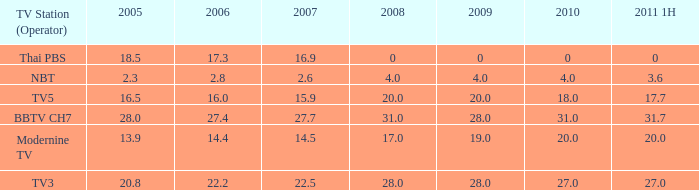What is the average 2007 value for a 2006 of 2.8 and 2009 under 20? 2.6. 